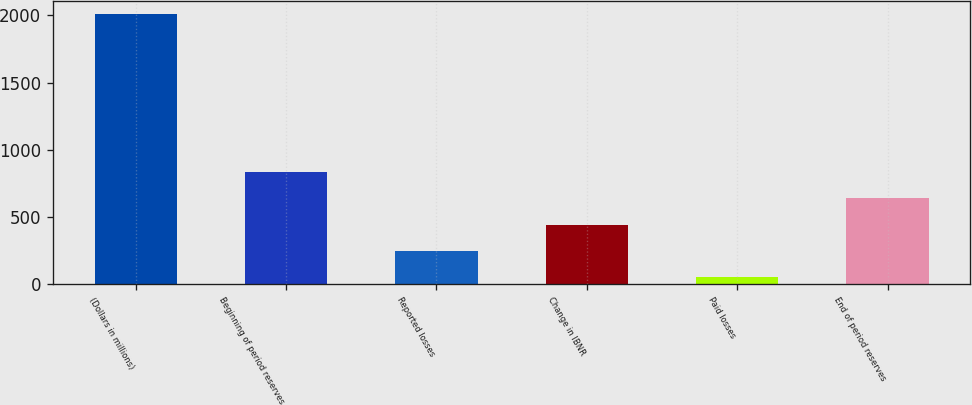Convert chart. <chart><loc_0><loc_0><loc_500><loc_500><bar_chart><fcel>(Dollars in millions)<fcel>Beginning of period reserves<fcel>Reported losses<fcel>Change in IBNR<fcel>Paid losses<fcel>End of period reserves<nl><fcel>2008<fcel>834.52<fcel>247.78<fcel>443.36<fcel>52.2<fcel>638.94<nl></chart> 